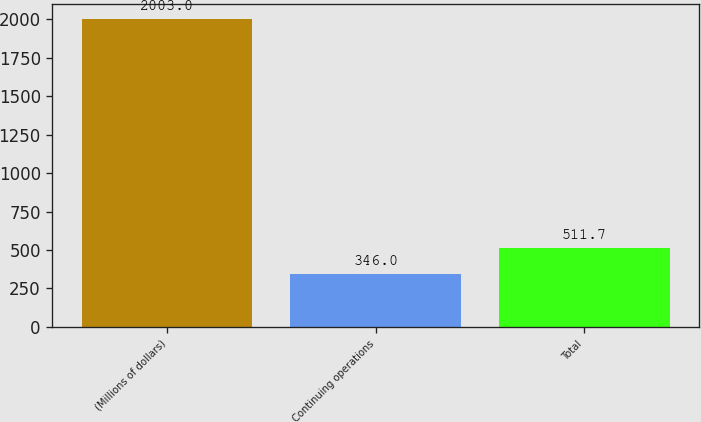<chart> <loc_0><loc_0><loc_500><loc_500><bar_chart><fcel>(Millions of dollars)<fcel>Continuing operations<fcel>Total<nl><fcel>2003<fcel>346<fcel>511.7<nl></chart> 